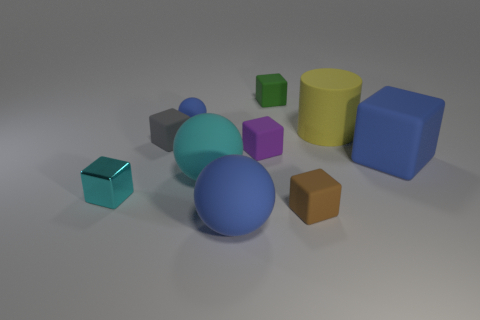Subtract all big cyan rubber balls. How many balls are left? 2 Subtract all blue cubes. How many cubes are left? 5 Subtract 1 blocks. How many blocks are left? 5 Subtract 1 purple blocks. How many objects are left? 9 Subtract all blocks. How many objects are left? 4 Subtract all brown blocks. Subtract all red cylinders. How many blocks are left? 5 Subtract all cyan balls. How many yellow cubes are left? 0 Subtract all large yellow rubber objects. Subtract all brown matte things. How many objects are left? 8 Add 4 tiny green cubes. How many tiny green cubes are left? 5 Add 8 yellow matte objects. How many yellow matte objects exist? 9 